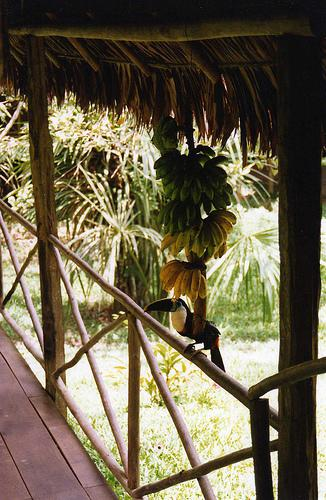Question: where are the bananas?
Choices:
A. On a plate.
B. In a basket.
C. In a bowl.
D. Hanging above bird.
Answer with the letter. Answer: D Question: when was this taken?
Choices:
A. At night.
B. In early morning.
C. At sunset.
D. Day time.
Answer with the letter. Answer: D Question: what kind of fruit is this?
Choices:
A. Bananas.
B. Apples.
C. Oranges.
D. Kiwis.
Answer with the letter. Answer: A 